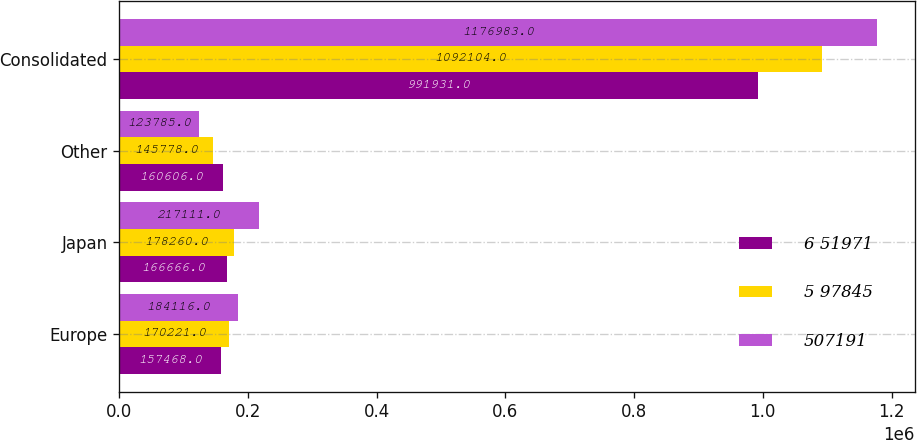<chart> <loc_0><loc_0><loc_500><loc_500><stacked_bar_chart><ecel><fcel>Europe<fcel>Japan<fcel>Other<fcel>Consolidated<nl><fcel>6 51971<fcel>157468<fcel>166666<fcel>160606<fcel>991931<nl><fcel>5 97845<fcel>170221<fcel>178260<fcel>145778<fcel>1.0921e+06<nl><fcel>507191<fcel>184116<fcel>217111<fcel>123785<fcel>1.17698e+06<nl></chart> 